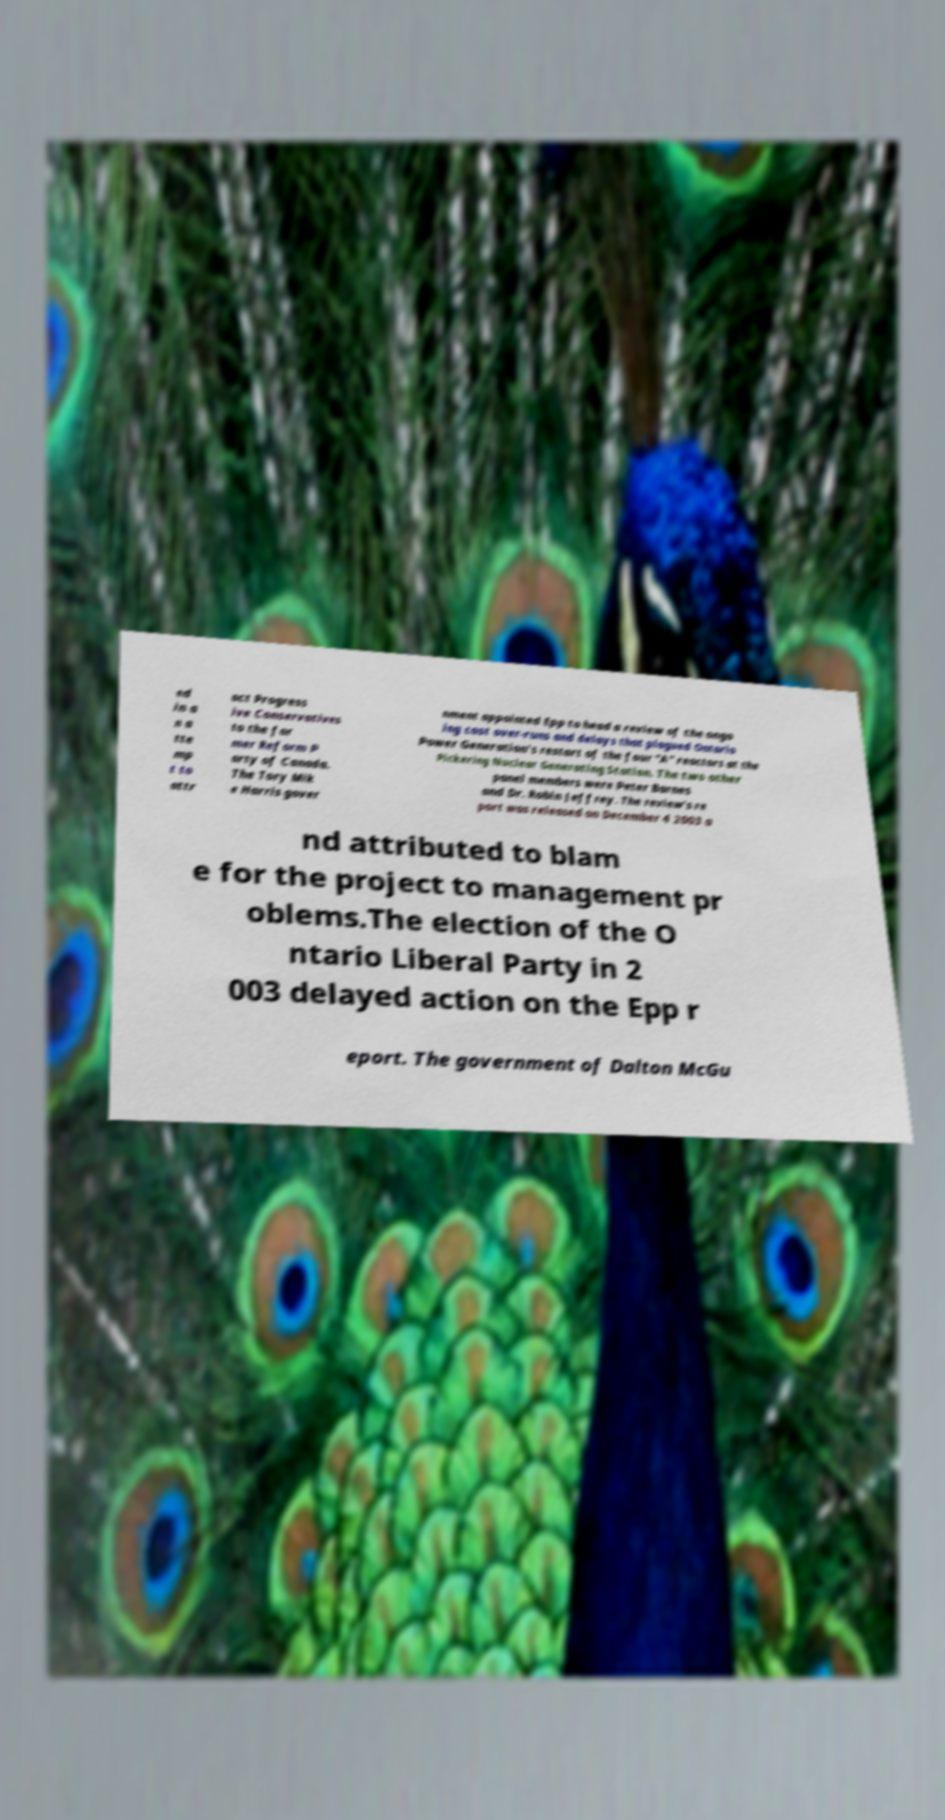What messages or text are displayed in this image? I need them in a readable, typed format. ed in a n a tte mp t to attr act Progress ive Conservatives to the for mer Reform P arty of Canada. The Tory Mik e Harris gover nment appointed Epp to head a review of the ongo ing cost over-runs and delays that plagued Ontario Power Generation's restart of the four "A" reactors at the Pickering Nuclear Generating Station. The two other panel members were Peter Barnes and Dr. Robin Jeffrey. The review's re port was released on December 4 2003 a nd attributed to blam e for the project to management pr oblems.The election of the O ntario Liberal Party in 2 003 delayed action on the Epp r eport. The government of Dalton McGu 